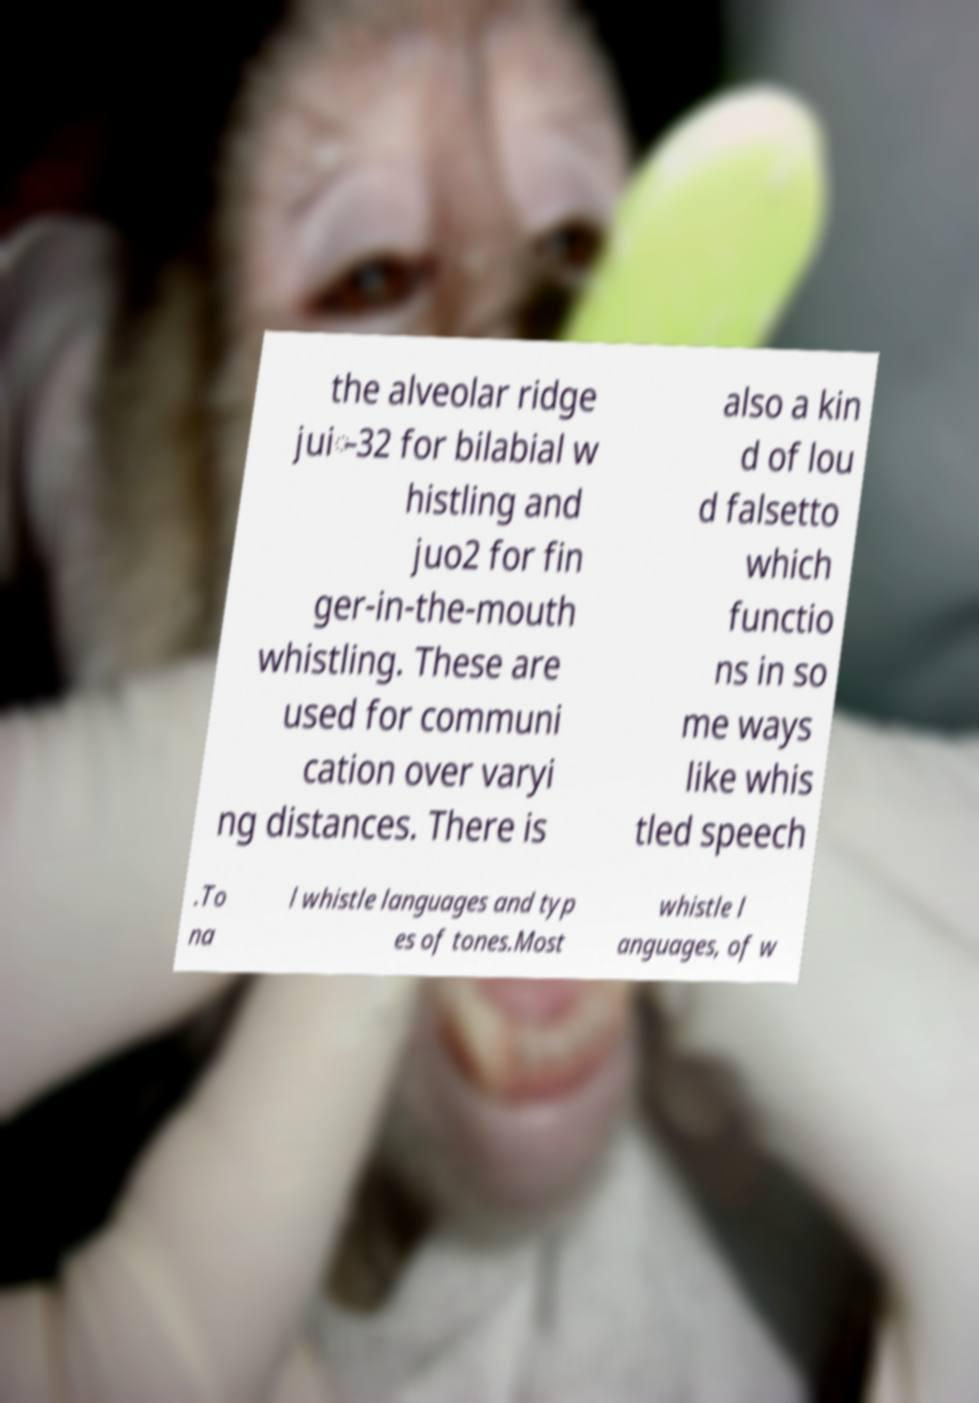What messages or text are displayed in this image? I need them in a readable, typed format. the alveolar ridge jui̵32 for bilabial w histling and juo2 for fin ger-in-the-mouth whistling. These are used for communi cation over varyi ng distances. There is also a kin d of lou d falsetto which functio ns in so me ways like whis tled speech .To na l whistle languages and typ es of tones.Most whistle l anguages, of w 